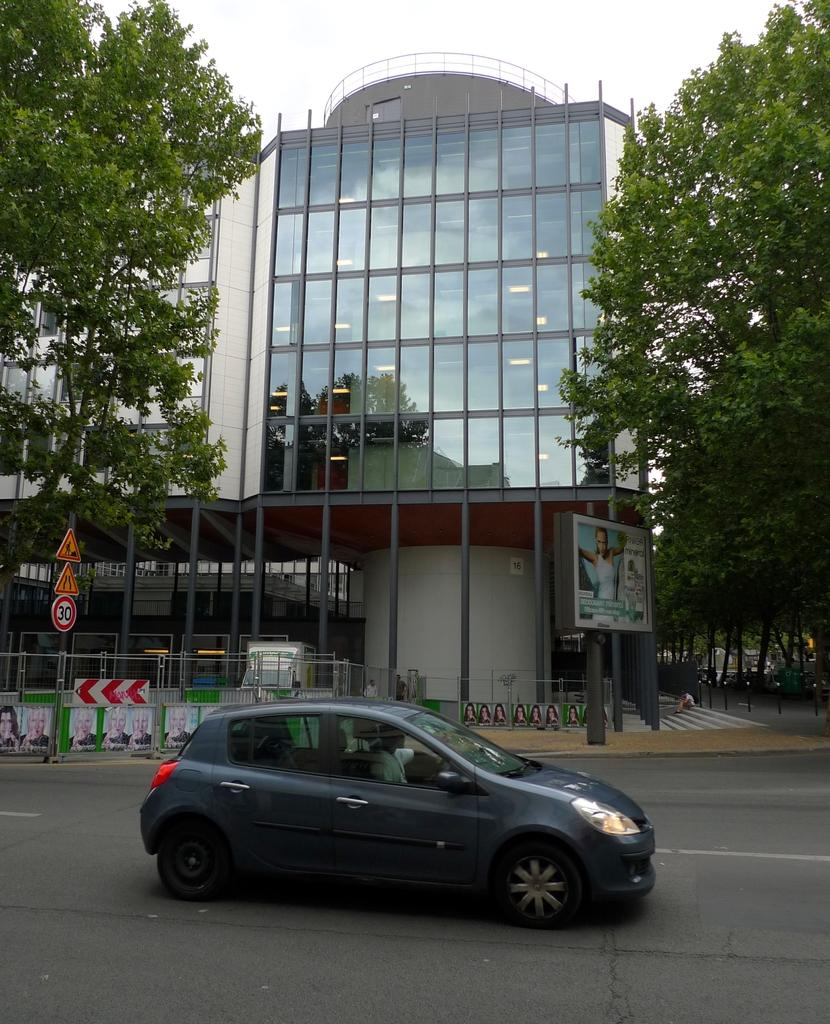What is the main subject of the image? There is a vehicle in the image. What is the vehicle doing in the image? The vehicle is moving on a road. What can be seen in the background of the image? There is a building and trees in the background of the image. How many men are wearing coats in the image? There are no men or coats present in the image; it features a vehicle moving on a road with a building and trees in the background. 